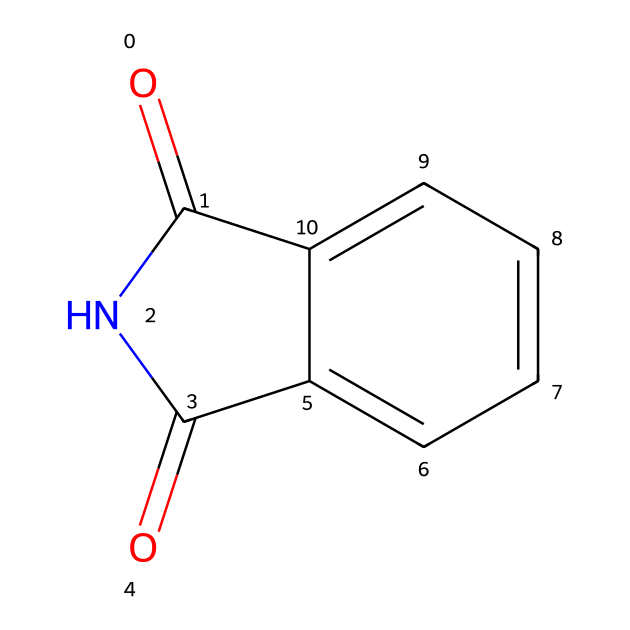What is the name of this chemical? The structure shown corresponds to phthalimide, which can be identified by its distinctive imide functional group along with its aromatic ring system.
Answer: phthalimide How many carbon atoms are in phthalimide? By analyzing the SMILES notation, there are eight carbon atoms present in the structure – six in the aromatic ring and two in the imide grouping.
Answer: eight What functional group is present in this compound? The chemical contains an imide functional group, which is defined by the presence of the carbonyl groups adjacent to the nitrogen atom.
Answer: imide How many nitrogen atoms are in phthalimide? The SMILES notation indicates there is one nitrogen atom in the molecular structure of phthalimide, as can be observed directly in the depicted arrangement.
Answer: one What type of bonding is present between the carbon atoms? The carbon atoms in the aromatic ring are connected by delocalized pi bonds, which is a characteristic of aromatic compounds, while the carbonyl groups are connected by single bonds to the nitrogen.
Answer: delocalized pi bonds Why does phthalimide have a solid-state at room temperature? The structure's extensive delocalization through resonance in the aromatic system, in combination with potential intermolecular interactions, contributes to its solid-state at room temperature.
Answer: resonance and intermolecular interactions What characteristic makes phthalimide suitable for use in plastics? Phthalimide's stability, thermal resistance, and the balance of its mechanical properties and chemical resistance are critical factors that make it suitable for plastic applications.
Answer: stability and thermal resistance 